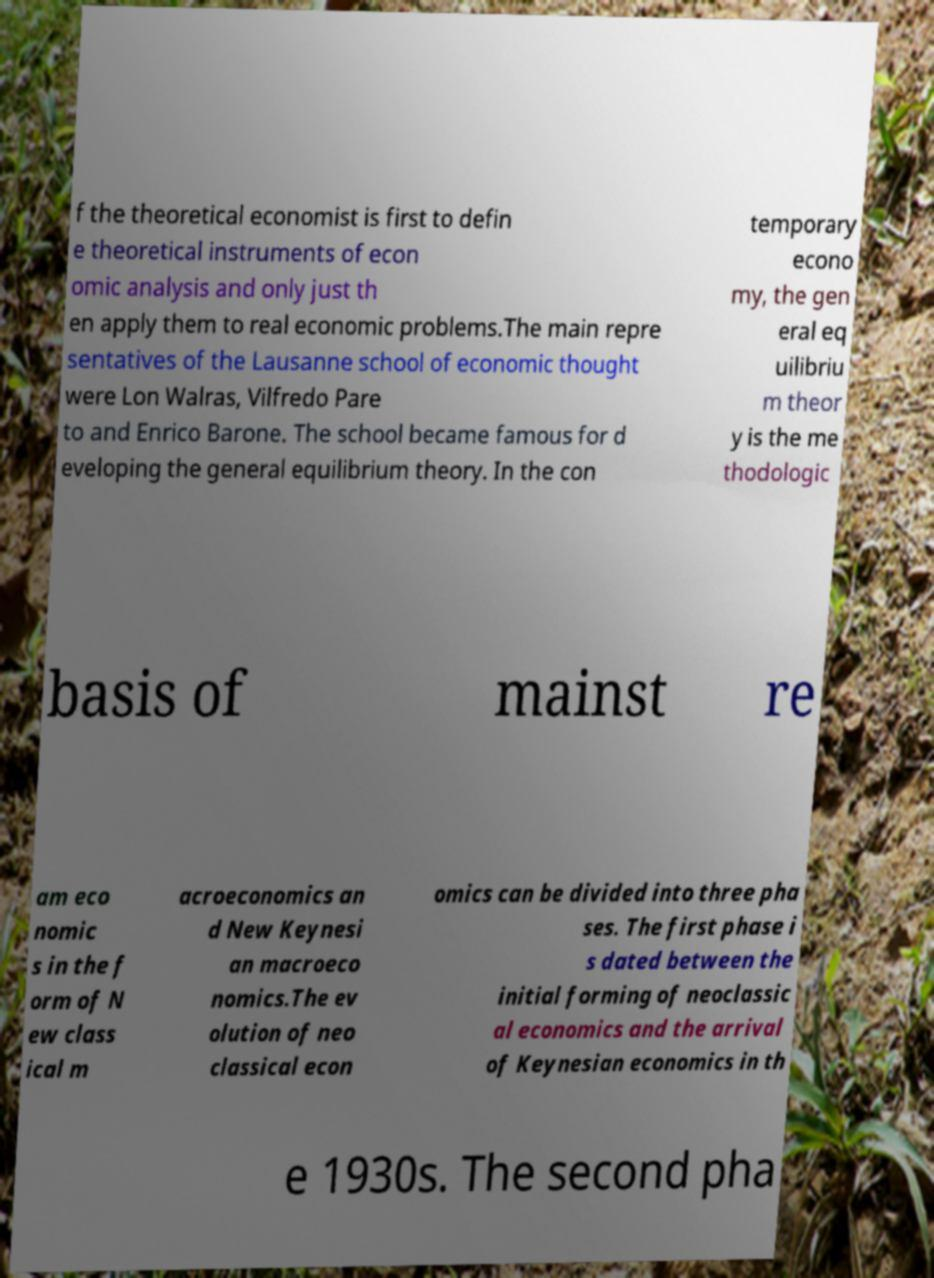There's text embedded in this image that I need extracted. Can you transcribe it verbatim? f the theoretical economist is first to defin e theoretical instruments of econ omic analysis and only just th en apply them to real economic problems.The main repre sentatives of the Lausanne school of economic thought were Lon Walras, Vilfredo Pare to and Enrico Barone. The school became famous for d eveloping the general equilibrium theory. In the con temporary econo my, the gen eral eq uilibriu m theor y is the me thodologic basis of mainst re am eco nomic s in the f orm of N ew class ical m acroeconomics an d New Keynesi an macroeco nomics.The ev olution of neo classical econ omics can be divided into three pha ses. The first phase i s dated between the initial forming of neoclassic al economics and the arrival of Keynesian economics in th e 1930s. The second pha 